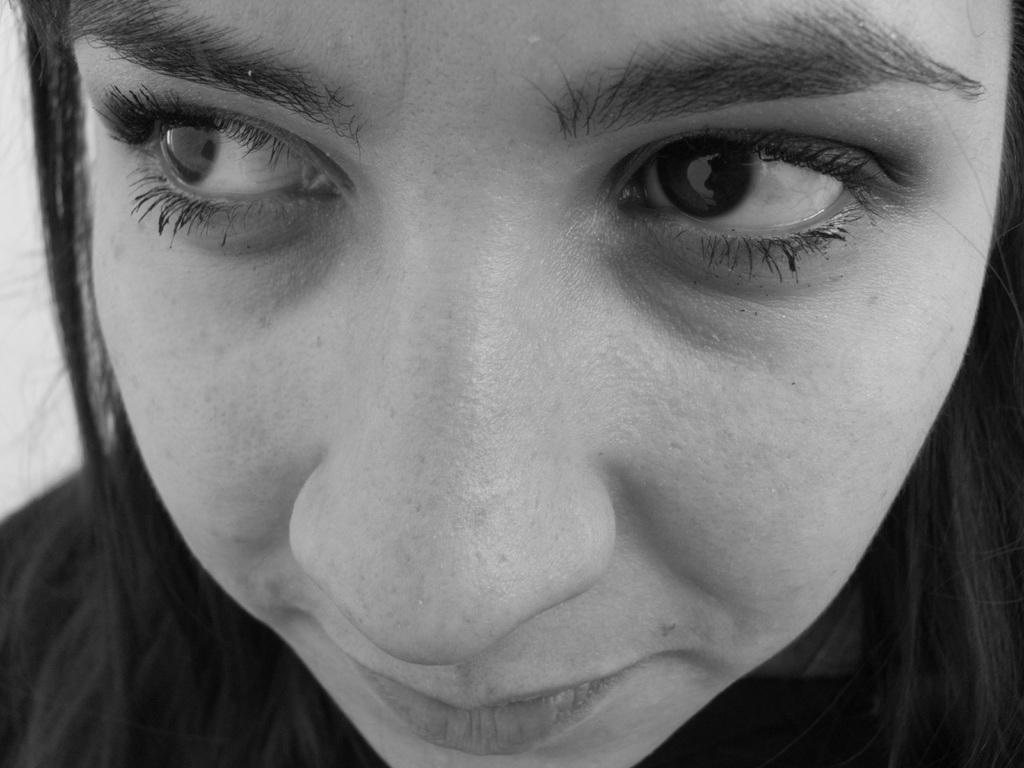Who is the main subject in the image? There is a woman in the picture. What is the woman wearing? The woman is wearing a black dress. In which direction is the woman looking? The woman is looking to the left side. Can you describe the background of the image? The backdrop of the image is blurred. What type of cream can be seen on the woman's face in the image? There is no cream visible on the woman's face in the image. 